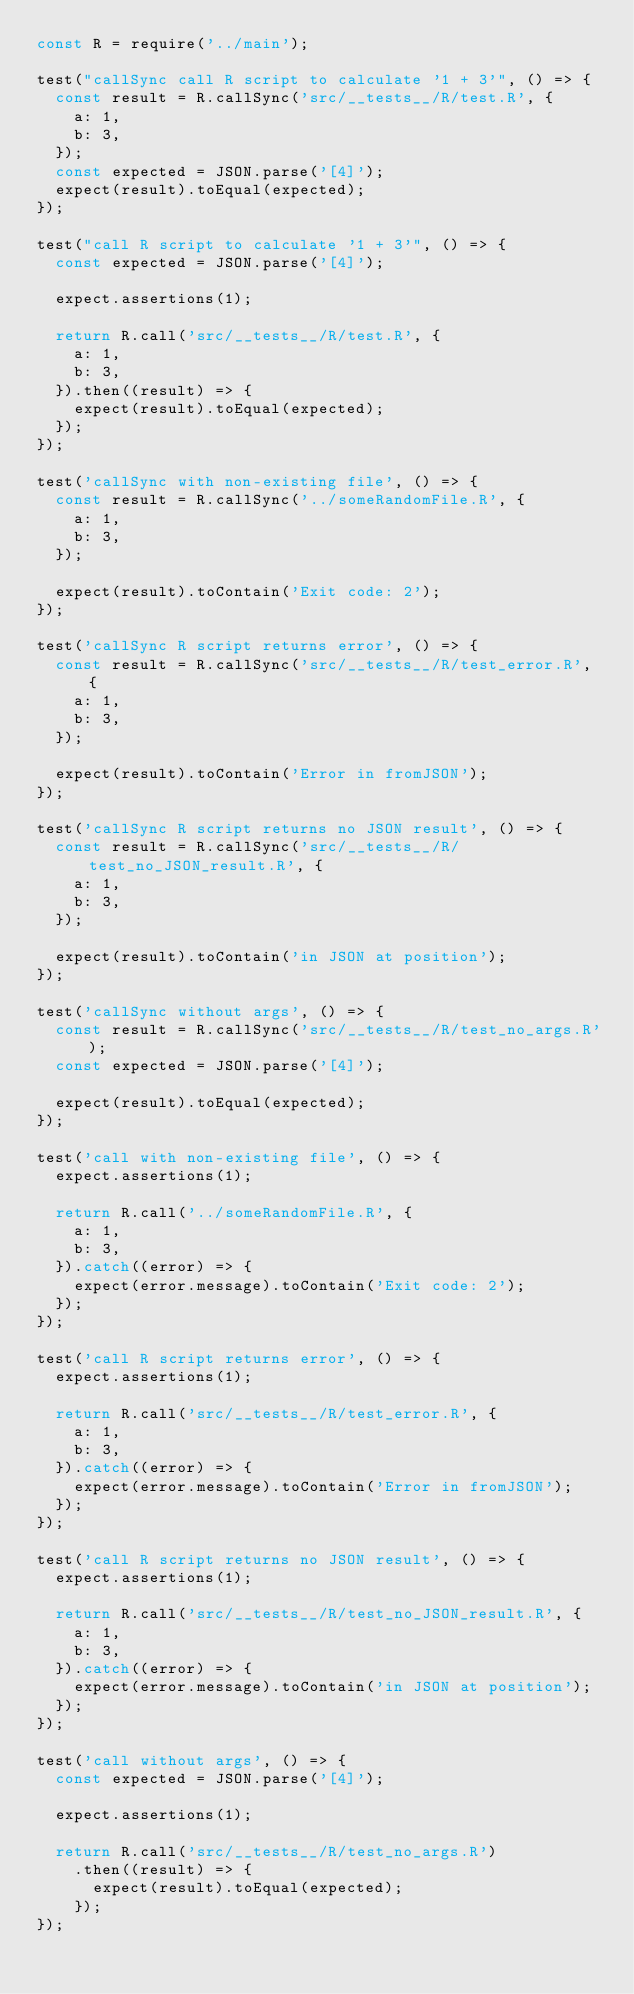<code> <loc_0><loc_0><loc_500><loc_500><_JavaScript_>const R = require('../main');

test("callSync call R script to calculate '1 + 3'", () => {
  const result = R.callSync('src/__tests__/R/test.R', {
    a: 1,
    b: 3,
  });
  const expected = JSON.parse('[4]');
  expect(result).toEqual(expected);
});

test("call R script to calculate '1 + 3'", () => {
  const expected = JSON.parse('[4]');

  expect.assertions(1);

  return R.call('src/__tests__/R/test.R', {
    a: 1,
    b: 3,
  }).then((result) => {
    expect(result).toEqual(expected);
  });
});

test('callSync with non-existing file', () => {
  const result = R.callSync('../someRandomFile.R', {
    a: 1,
    b: 3,
  });

  expect(result).toContain('Exit code: 2');
});

test('callSync R script returns error', () => {
  const result = R.callSync('src/__tests__/R/test_error.R', {
    a: 1,
    b: 3,
  });

  expect(result).toContain('Error in fromJSON');
});

test('callSync R script returns no JSON result', () => {
  const result = R.callSync('src/__tests__/R/test_no_JSON_result.R', {
    a: 1,
    b: 3,
  });

  expect(result).toContain('in JSON at position');
});

test('callSync without args', () => {
  const result = R.callSync('src/__tests__/R/test_no_args.R');
  const expected = JSON.parse('[4]');

  expect(result).toEqual(expected);
});

test('call with non-existing file', () => {
  expect.assertions(1);

  return R.call('../someRandomFile.R', {
    a: 1,
    b: 3,
  }).catch((error) => {
    expect(error.message).toContain('Exit code: 2');
  });
});

test('call R script returns error', () => {
  expect.assertions(1);

  return R.call('src/__tests__/R/test_error.R', {
    a: 1,
    b: 3,
  }).catch((error) => {
    expect(error.message).toContain('Error in fromJSON');
  });
});

test('call R script returns no JSON result', () => {
  expect.assertions(1);

  return R.call('src/__tests__/R/test_no_JSON_result.R', {
    a: 1,
    b: 3,
  }).catch((error) => {
    expect(error.message).toContain('in JSON at position');
  });
});

test('call without args', () => {
  const expected = JSON.parse('[4]');

  expect.assertions(1);

  return R.call('src/__tests__/R/test_no_args.R')
    .then((result) => {
      expect(result).toEqual(expected);
    });
});
</code> 